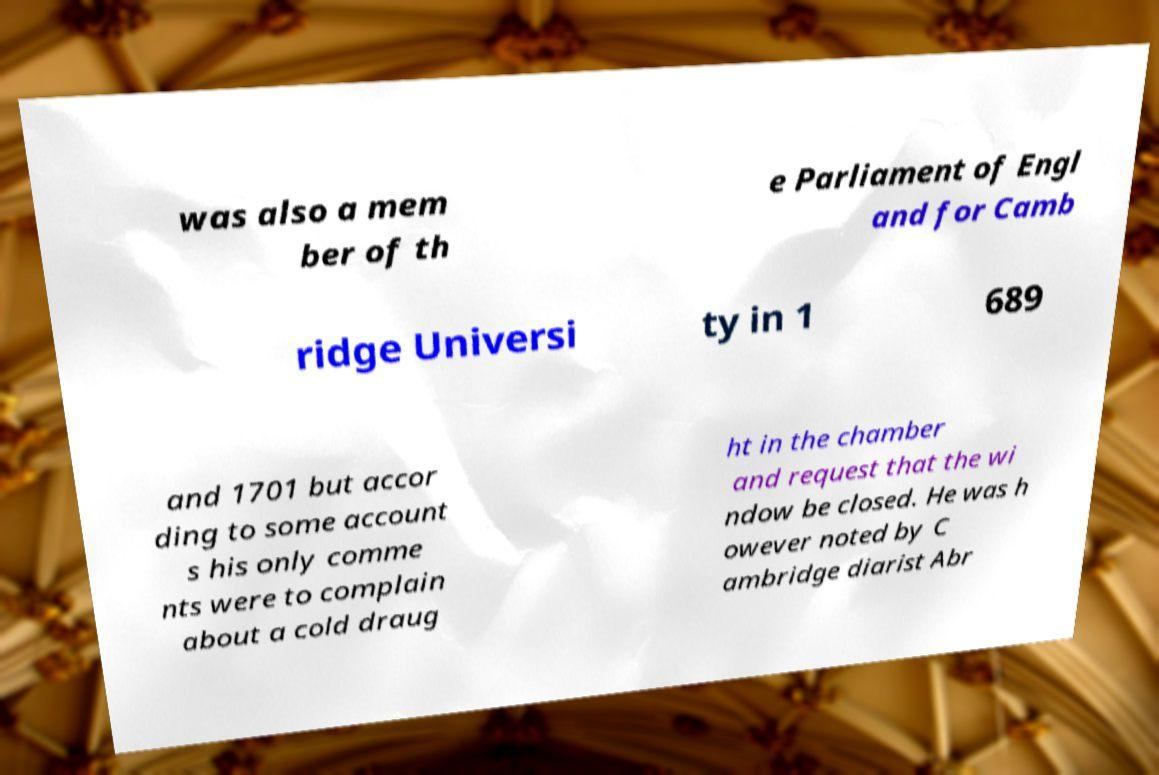Could you extract and type out the text from this image? was also a mem ber of th e Parliament of Engl and for Camb ridge Universi ty in 1 689 and 1701 but accor ding to some account s his only comme nts were to complain about a cold draug ht in the chamber and request that the wi ndow be closed. He was h owever noted by C ambridge diarist Abr 